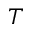<formula> <loc_0><loc_0><loc_500><loc_500>T</formula> 